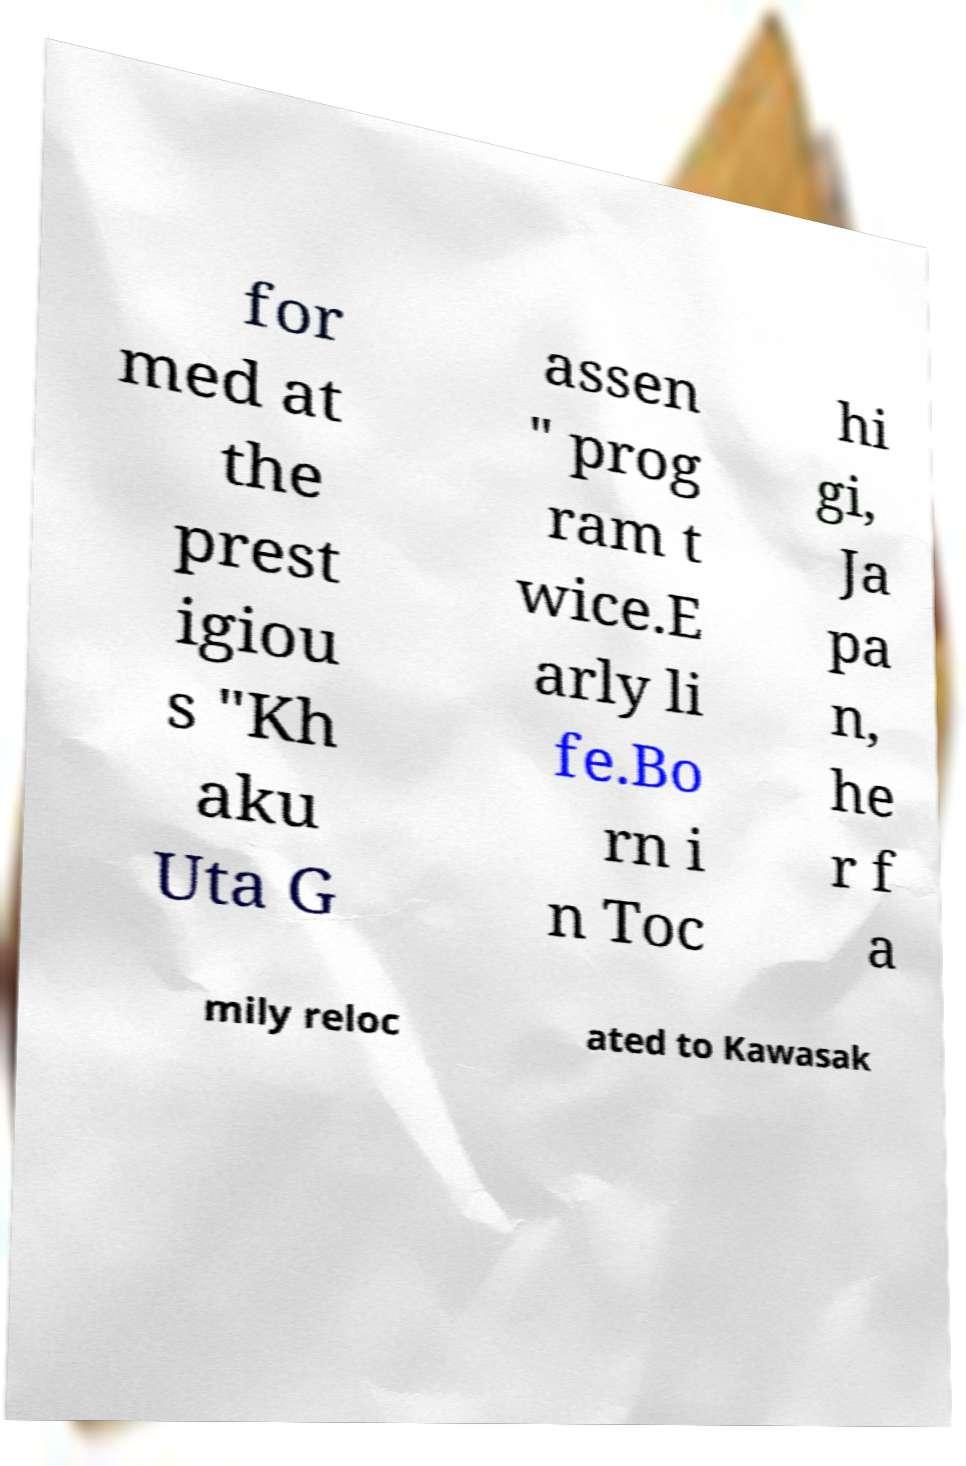Please read and relay the text visible in this image. What does it say? for med at the prest igiou s "Kh aku Uta G assen " prog ram t wice.E arly li fe.Bo rn i n Toc hi gi, Ja pa n, he r f a mily reloc ated to Kawasak 